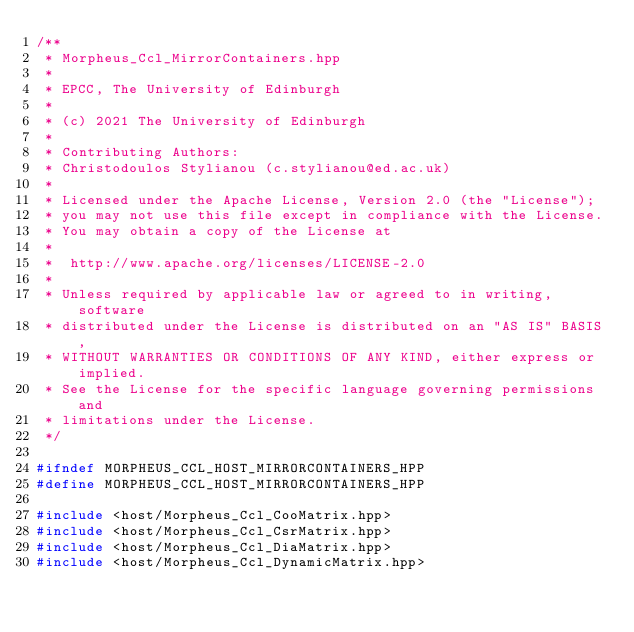Convert code to text. <code><loc_0><loc_0><loc_500><loc_500><_C++_>/**
 * Morpheus_Ccl_MirrorContainers.hpp
 *
 * EPCC, The University of Edinburgh
 *
 * (c) 2021 The University of Edinburgh
 *
 * Contributing Authors:
 * Christodoulos Stylianou (c.stylianou@ed.ac.uk)
 *
 * Licensed under the Apache License, Version 2.0 (the "License");
 * you may not use this file except in compliance with the License.
 * You may obtain a copy of the License at
 *
 * 	http://www.apache.org/licenses/LICENSE-2.0
 *
 * Unless required by applicable law or agreed to in writing, software
 * distributed under the License is distributed on an "AS IS" BASIS,
 * WITHOUT WARRANTIES OR CONDITIONS OF ANY KIND, either express or implied.
 * See the License for the specific language governing permissions and
 * limitations under the License.
 */

#ifndef MORPHEUS_CCL_HOST_MIRRORCONTAINERS_HPP
#define MORPHEUS_CCL_HOST_MIRRORCONTAINERS_HPP

#include <host/Morpheus_Ccl_CooMatrix.hpp>
#include <host/Morpheus_Ccl_CsrMatrix.hpp>
#include <host/Morpheus_Ccl_DiaMatrix.hpp>
#include <host/Morpheus_Ccl_DynamicMatrix.hpp></code> 